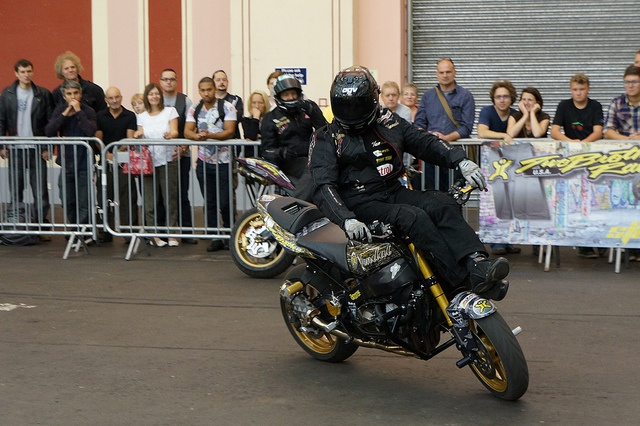Describe the objects in this image and their specific colors. I can see motorcycle in brown, black, gray, olive, and darkgray tones, people in brown, black, gray, darkgray, and lightgray tones, people in brown, black, gray, and darkgray tones, people in brown, black, gray, darkgray, and lightgray tones, and motorcycle in brown, black, gray, darkgray, and lightgray tones in this image. 